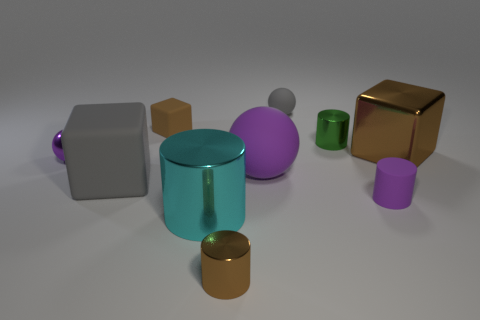Subtract 2 cylinders. How many cylinders are left? 2 Subtract all cubes. How many objects are left? 7 Subtract 1 brown cylinders. How many objects are left? 9 Subtract all brown spheres. Subtract all large brown metal cubes. How many objects are left? 9 Add 2 large gray blocks. How many large gray blocks are left? 3 Add 5 purple cylinders. How many purple cylinders exist? 6 